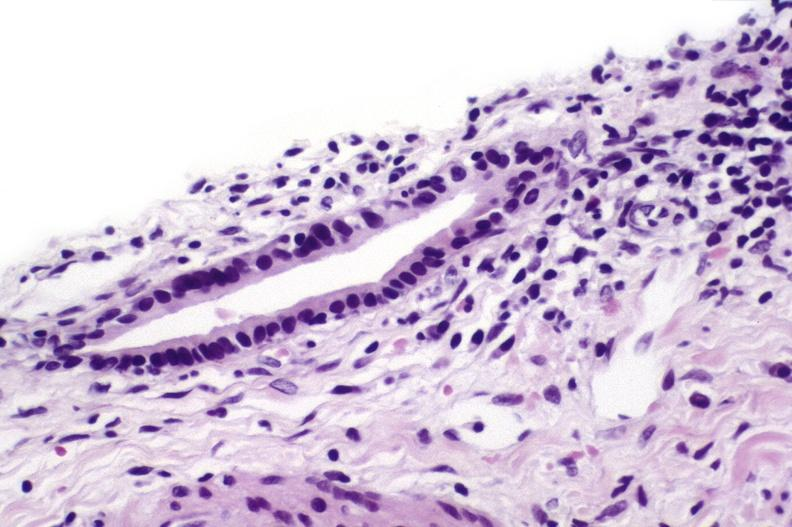s myocardial infarct present?
Answer the question using a single word or phrase. No 